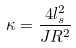Convert formula to latex. <formula><loc_0><loc_0><loc_500><loc_500>\kappa = \frac { 4 l _ { s } ^ { 2 } } { J R ^ { 2 } }</formula> 